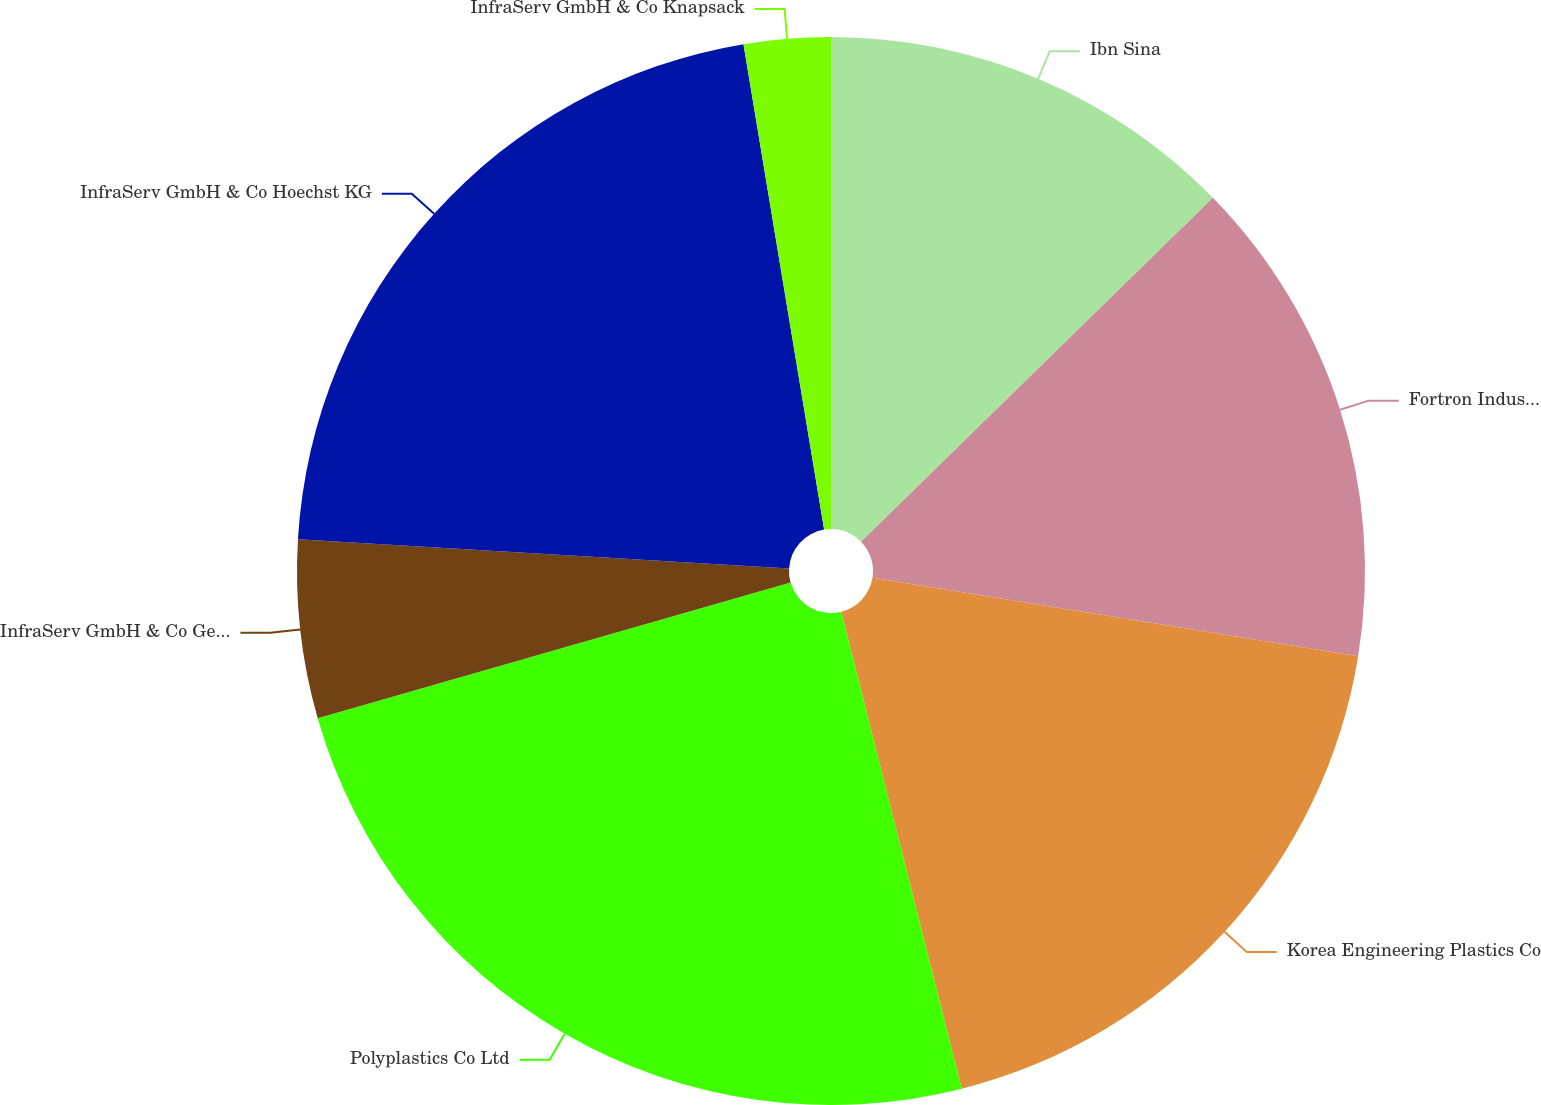Convert chart. <chart><loc_0><loc_0><loc_500><loc_500><pie_chart><fcel>Ibn Sina<fcel>Fortron Industries LLC<fcel>Korea Engineering Plastics Co<fcel>Polyplastics Co Ltd<fcel>InfraServ GmbH & Co Gendorf KG<fcel>InfraServ GmbH & Co Hoechst KG<fcel>InfraServ GmbH & Co Knapsack<nl><fcel>12.68%<fcel>14.87%<fcel>18.51%<fcel>24.49%<fcel>5.39%<fcel>21.43%<fcel>2.62%<nl></chart> 